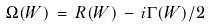Convert formula to latex. <formula><loc_0><loc_0><loc_500><loc_500>\Omega ( W ) \, = \, R ( W ) \, - \, i \Gamma ( W ) / 2</formula> 